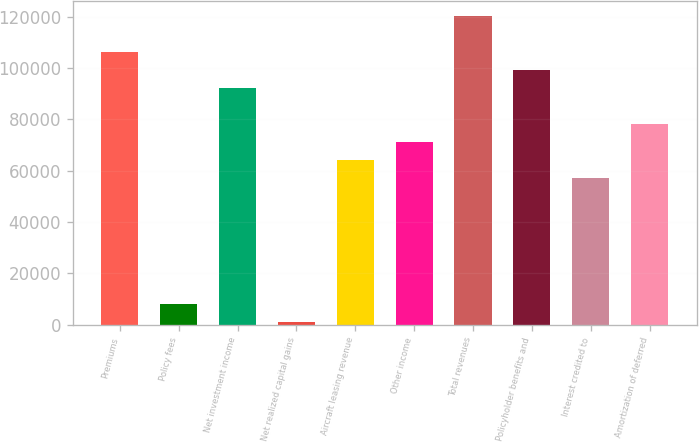<chart> <loc_0><loc_0><loc_500><loc_500><bar_chart><fcel>Premiums<fcel>Policy fees<fcel>Net investment income<fcel>Net realized capital gains<fcel>Aircraft leasing revenue<fcel>Other income<fcel>Total revenues<fcel>Policyholder benefits and<fcel>Interest credited to<fcel>Amortization of deferred<nl><fcel>106278<fcel>8099.7<fcel>92252.1<fcel>1087<fcel>64201.3<fcel>71214<fcel>120303<fcel>99264.8<fcel>57188.6<fcel>78226.7<nl></chart> 